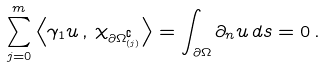<formula> <loc_0><loc_0><loc_500><loc_500>\sum _ { j = 0 } ^ { m } \left \langle \gamma _ { 1 } u \, , \, \chi _ { \partial \Omega ^ { \complement } _ { ( j ) } } \right \rangle = \int _ { \partial \Omega } \partial _ { n } u \, d s = 0 \, .</formula> 